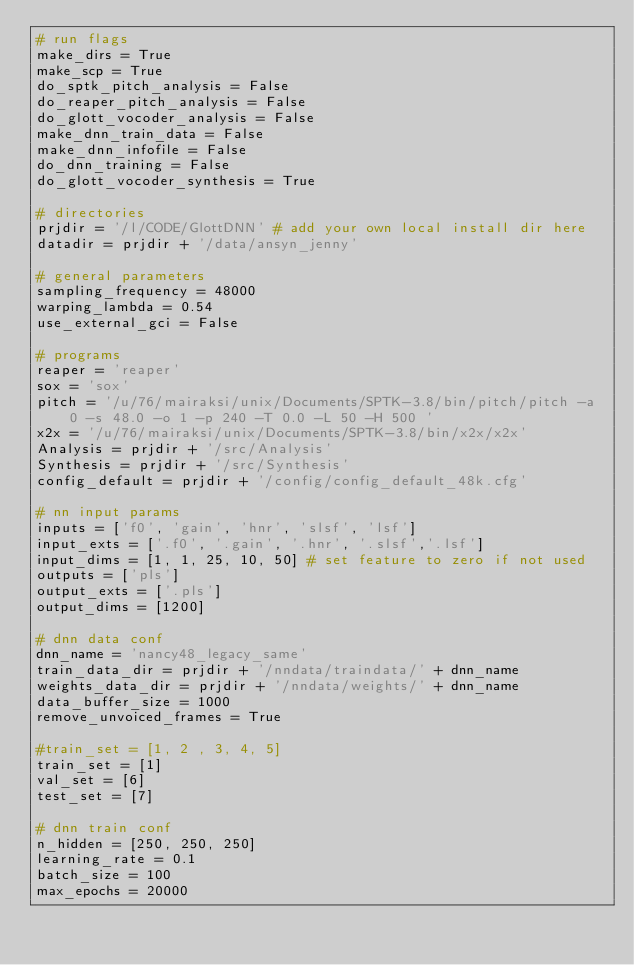Convert code to text. <code><loc_0><loc_0><loc_500><loc_500><_Python_># run flags
make_dirs = True
make_scp = True
do_sptk_pitch_analysis = False
do_reaper_pitch_analysis = False
do_glott_vocoder_analysis = False
make_dnn_train_data = False
make_dnn_infofile = False
do_dnn_training = False
do_glott_vocoder_synthesis = True

# directories
prjdir = '/l/CODE/GlottDNN' # add your own local install dir here
datadir = prjdir + '/data/ansyn_jenny'

# general parameters
sampling_frequency = 48000
warping_lambda = 0.54
use_external_gci = False

# programs
reaper = 'reaper'
sox = 'sox'
pitch = '/u/76/mairaksi/unix/Documents/SPTK-3.8/bin/pitch/pitch -a 0 -s 48.0 -o 1 -p 240 -T 0.0 -L 50 -H 500 '
x2x = '/u/76/mairaksi/unix/Documents/SPTK-3.8/bin/x2x/x2x'
Analysis = prjdir + '/src/Analysis'
Synthesis = prjdir + '/src/Synthesis'
config_default = prjdir + '/config/config_default_48k.cfg'

# nn input params
inputs = ['f0', 'gain', 'hnr', 'slsf', 'lsf']
input_exts = ['.f0', '.gain', '.hnr', '.slsf','.lsf']
input_dims = [1, 1, 25, 10, 50] # set feature to zero if not used
outputs = ['pls']
output_exts = ['.pls']
output_dims = [1200]

# dnn data conf
dnn_name = 'nancy48_legacy_same'
train_data_dir = prjdir + '/nndata/traindata/' + dnn_name 
weights_data_dir = prjdir + '/nndata/weights/' + dnn_name
data_buffer_size = 1000
remove_unvoiced_frames = True

#train_set = [1, 2 , 3, 4, 5]
train_set = [1]
val_set = [6]
test_set = [7]

# dnn train conf
n_hidden = [250, 250, 250]
learning_rate = 0.1
batch_size = 100
max_epochs = 20000
</code> 